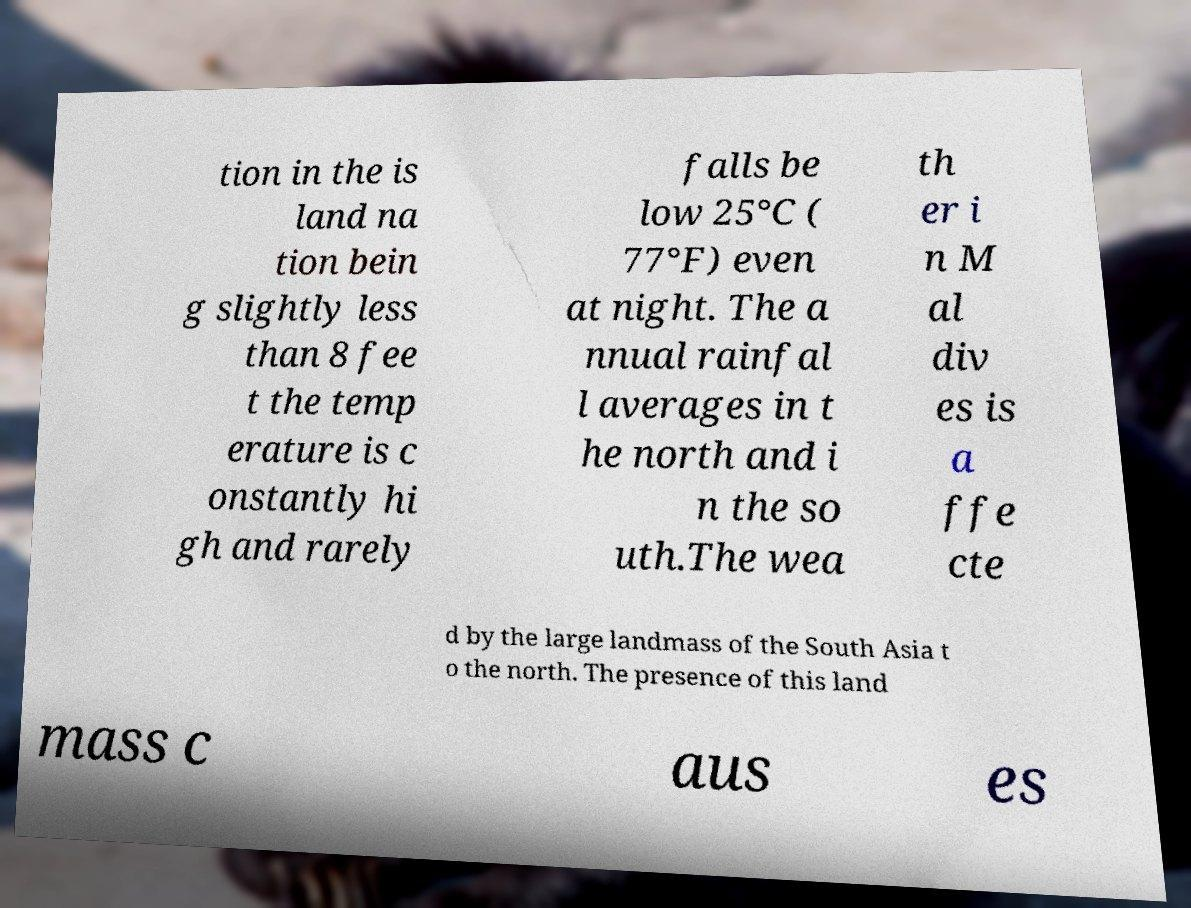There's text embedded in this image that I need extracted. Can you transcribe it verbatim? tion in the is land na tion bein g slightly less than 8 fee t the temp erature is c onstantly hi gh and rarely falls be low 25°C ( 77°F) even at night. The a nnual rainfal l averages in t he north and i n the so uth.The wea th er i n M al div es is a ffe cte d by the large landmass of the South Asia t o the north. The presence of this land mass c aus es 